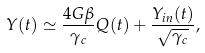Convert formula to latex. <formula><loc_0><loc_0><loc_500><loc_500>Y ( t ) \simeq \frac { 4 G \beta } { \gamma _ { c } } Q ( t ) + \frac { Y _ { i n } ( t ) } { \sqrt { \gamma _ { c } } } ,</formula> 